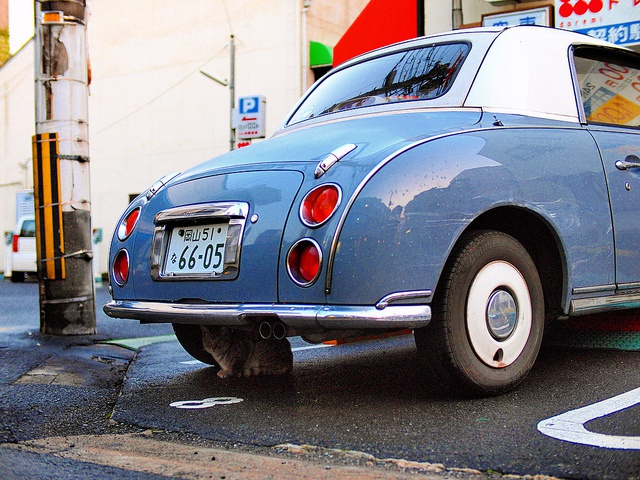Describe the objects in this image and their specific colors. I can see car in tan, white, black, gray, and lightblue tones, cat in tan, black, maroon, and gray tones, truck in tan, lavender, black, teal, and darkgray tones, and parking meter in tan, lavender, and blue tones in this image. 